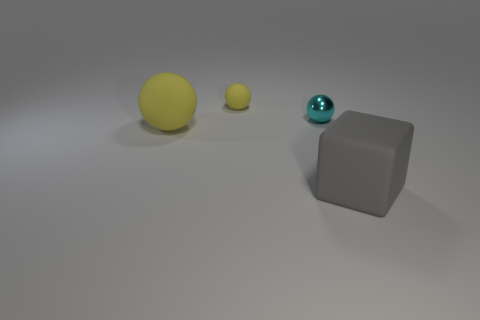There is a shiny sphere; how many small yellow rubber spheres are to the left of it?
Give a very brief answer. 1. Are there more yellow matte objects that are in front of the big gray rubber block than big yellow cylinders?
Keep it short and to the point. No. There is a small thing that is the same material as the large block; what is its shape?
Offer a very short reply. Sphere. There is a matte thing that is in front of the yellow sphere in front of the small cyan ball; what is its color?
Keep it short and to the point. Gray. Does the gray matte thing have the same shape as the cyan thing?
Your answer should be compact. No. There is another small object that is the same shape as the cyan thing; what is it made of?
Make the answer very short. Rubber. There is a yellow rubber ball behind the large rubber thing that is on the left side of the small matte ball; are there any large matte blocks that are in front of it?
Keep it short and to the point. Yes. There is a big yellow matte object; is it the same shape as the big matte thing to the right of the big yellow rubber sphere?
Ensure brevity in your answer.  No. Is there anything else that is the same color as the tiny matte thing?
Provide a short and direct response. Yes. There is a large matte thing that is left of the small yellow matte object; is its color the same as the tiny ball that is behind the metallic sphere?
Your answer should be compact. Yes. 